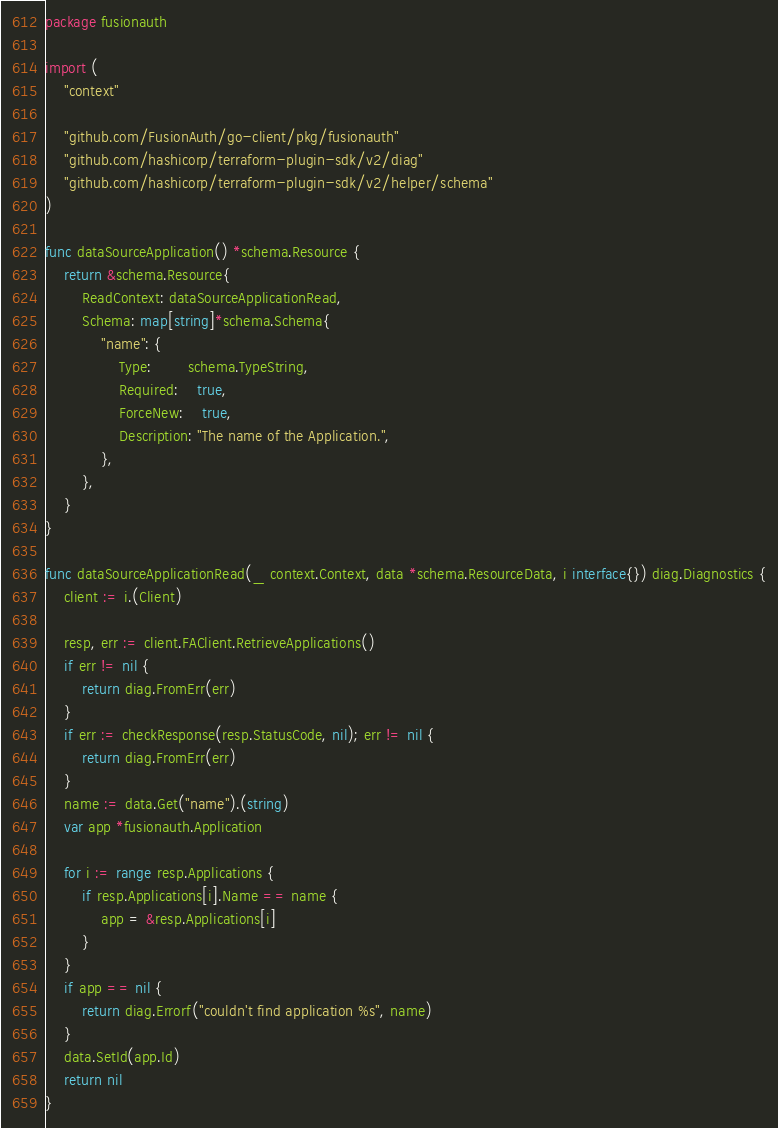<code> <loc_0><loc_0><loc_500><loc_500><_Go_>package fusionauth

import (
	"context"

	"github.com/FusionAuth/go-client/pkg/fusionauth"
	"github.com/hashicorp/terraform-plugin-sdk/v2/diag"
	"github.com/hashicorp/terraform-plugin-sdk/v2/helper/schema"
)

func dataSourceApplication() *schema.Resource {
	return &schema.Resource{
		ReadContext: dataSourceApplicationRead,
		Schema: map[string]*schema.Schema{
			"name": {
				Type:        schema.TypeString,
				Required:    true,
				ForceNew:    true,
				Description: "The name of the Application.",
			},
		},
	}
}

func dataSourceApplicationRead(_ context.Context, data *schema.ResourceData, i interface{}) diag.Diagnostics {
	client := i.(Client)

	resp, err := client.FAClient.RetrieveApplications()
	if err != nil {
		return diag.FromErr(err)
	}
	if err := checkResponse(resp.StatusCode, nil); err != nil {
		return diag.FromErr(err)
	}
	name := data.Get("name").(string)
	var app *fusionauth.Application

	for i := range resp.Applications {
		if resp.Applications[i].Name == name {
			app = &resp.Applications[i]
		}
	}
	if app == nil {
		return diag.Errorf("couldn't find application %s", name)
	}
	data.SetId(app.Id)
	return nil
}
</code> 